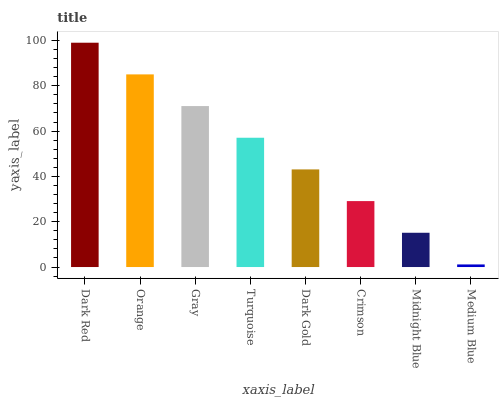Is Orange the minimum?
Answer yes or no. No. Is Orange the maximum?
Answer yes or no. No. Is Dark Red greater than Orange?
Answer yes or no. Yes. Is Orange less than Dark Red?
Answer yes or no. Yes. Is Orange greater than Dark Red?
Answer yes or no. No. Is Dark Red less than Orange?
Answer yes or no. No. Is Turquoise the high median?
Answer yes or no. Yes. Is Dark Gold the low median?
Answer yes or no. Yes. Is Dark Gold the high median?
Answer yes or no. No. Is Orange the low median?
Answer yes or no. No. 